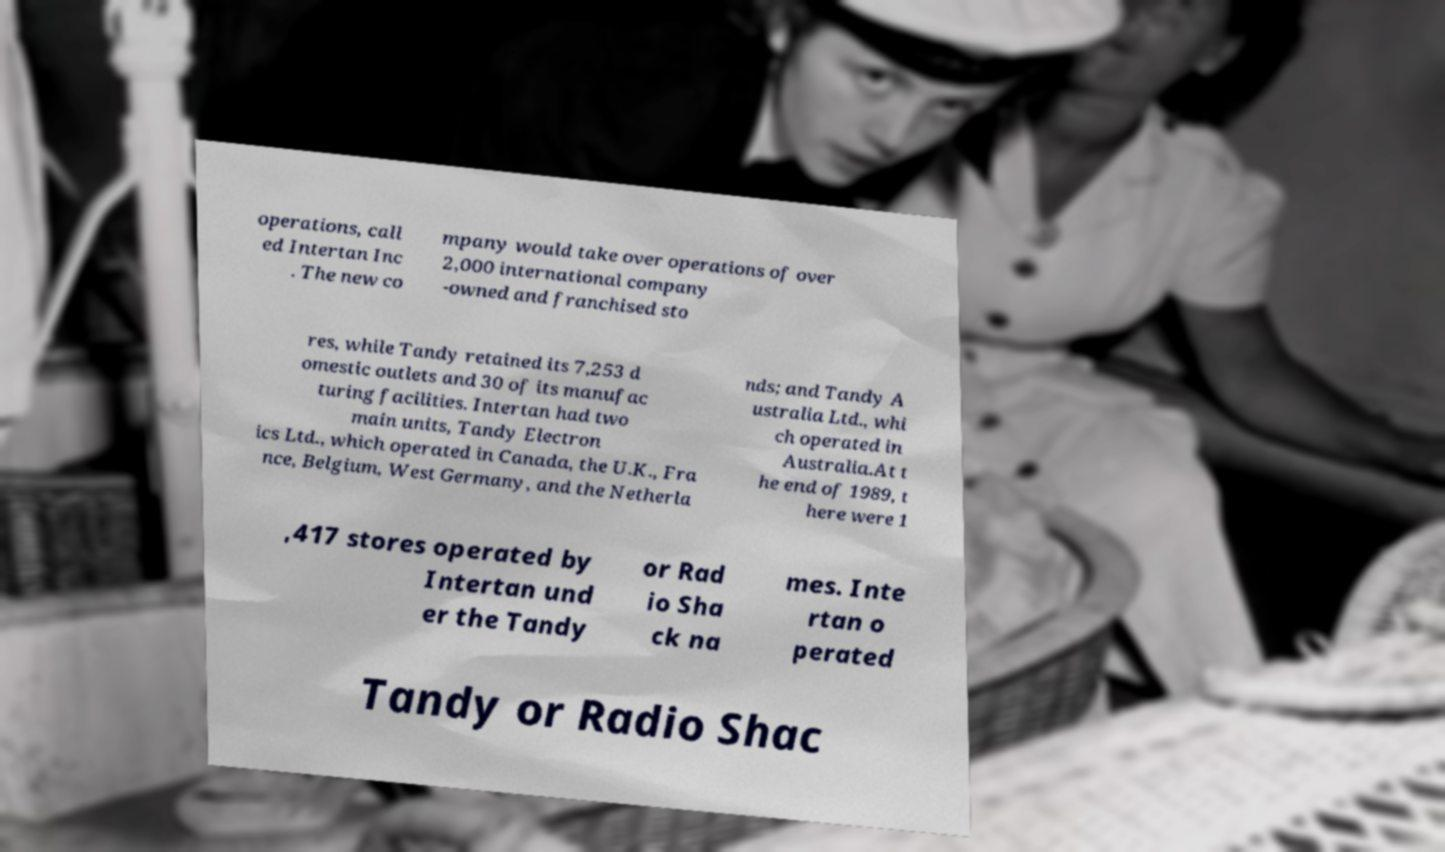Can you accurately transcribe the text from the provided image for me? operations, call ed Intertan Inc . The new co mpany would take over operations of over 2,000 international company -owned and franchised sto res, while Tandy retained its 7,253 d omestic outlets and 30 of its manufac turing facilities. Intertan had two main units, Tandy Electron ics Ltd., which operated in Canada, the U.K., Fra nce, Belgium, West Germany, and the Netherla nds; and Tandy A ustralia Ltd., whi ch operated in Australia.At t he end of 1989, t here were 1 ,417 stores operated by Intertan und er the Tandy or Rad io Sha ck na mes. Inte rtan o perated Tandy or Radio Shac 